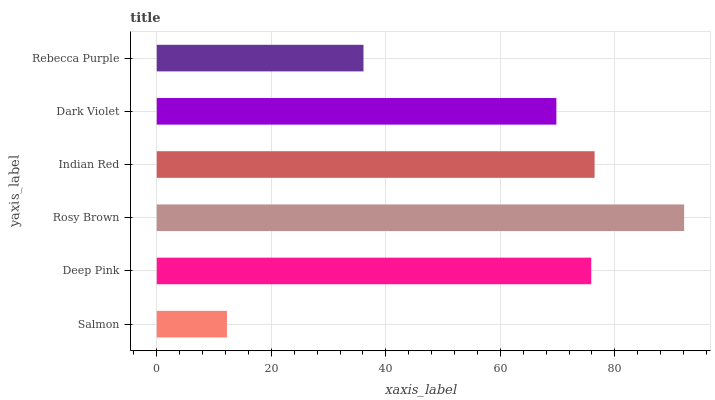Is Salmon the minimum?
Answer yes or no. Yes. Is Rosy Brown the maximum?
Answer yes or no. Yes. Is Deep Pink the minimum?
Answer yes or no. No. Is Deep Pink the maximum?
Answer yes or no. No. Is Deep Pink greater than Salmon?
Answer yes or no. Yes. Is Salmon less than Deep Pink?
Answer yes or no. Yes. Is Salmon greater than Deep Pink?
Answer yes or no. No. Is Deep Pink less than Salmon?
Answer yes or no. No. Is Deep Pink the high median?
Answer yes or no. Yes. Is Dark Violet the low median?
Answer yes or no. Yes. Is Salmon the high median?
Answer yes or no. No. Is Salmon the low median?
Answer yes or no. No. 